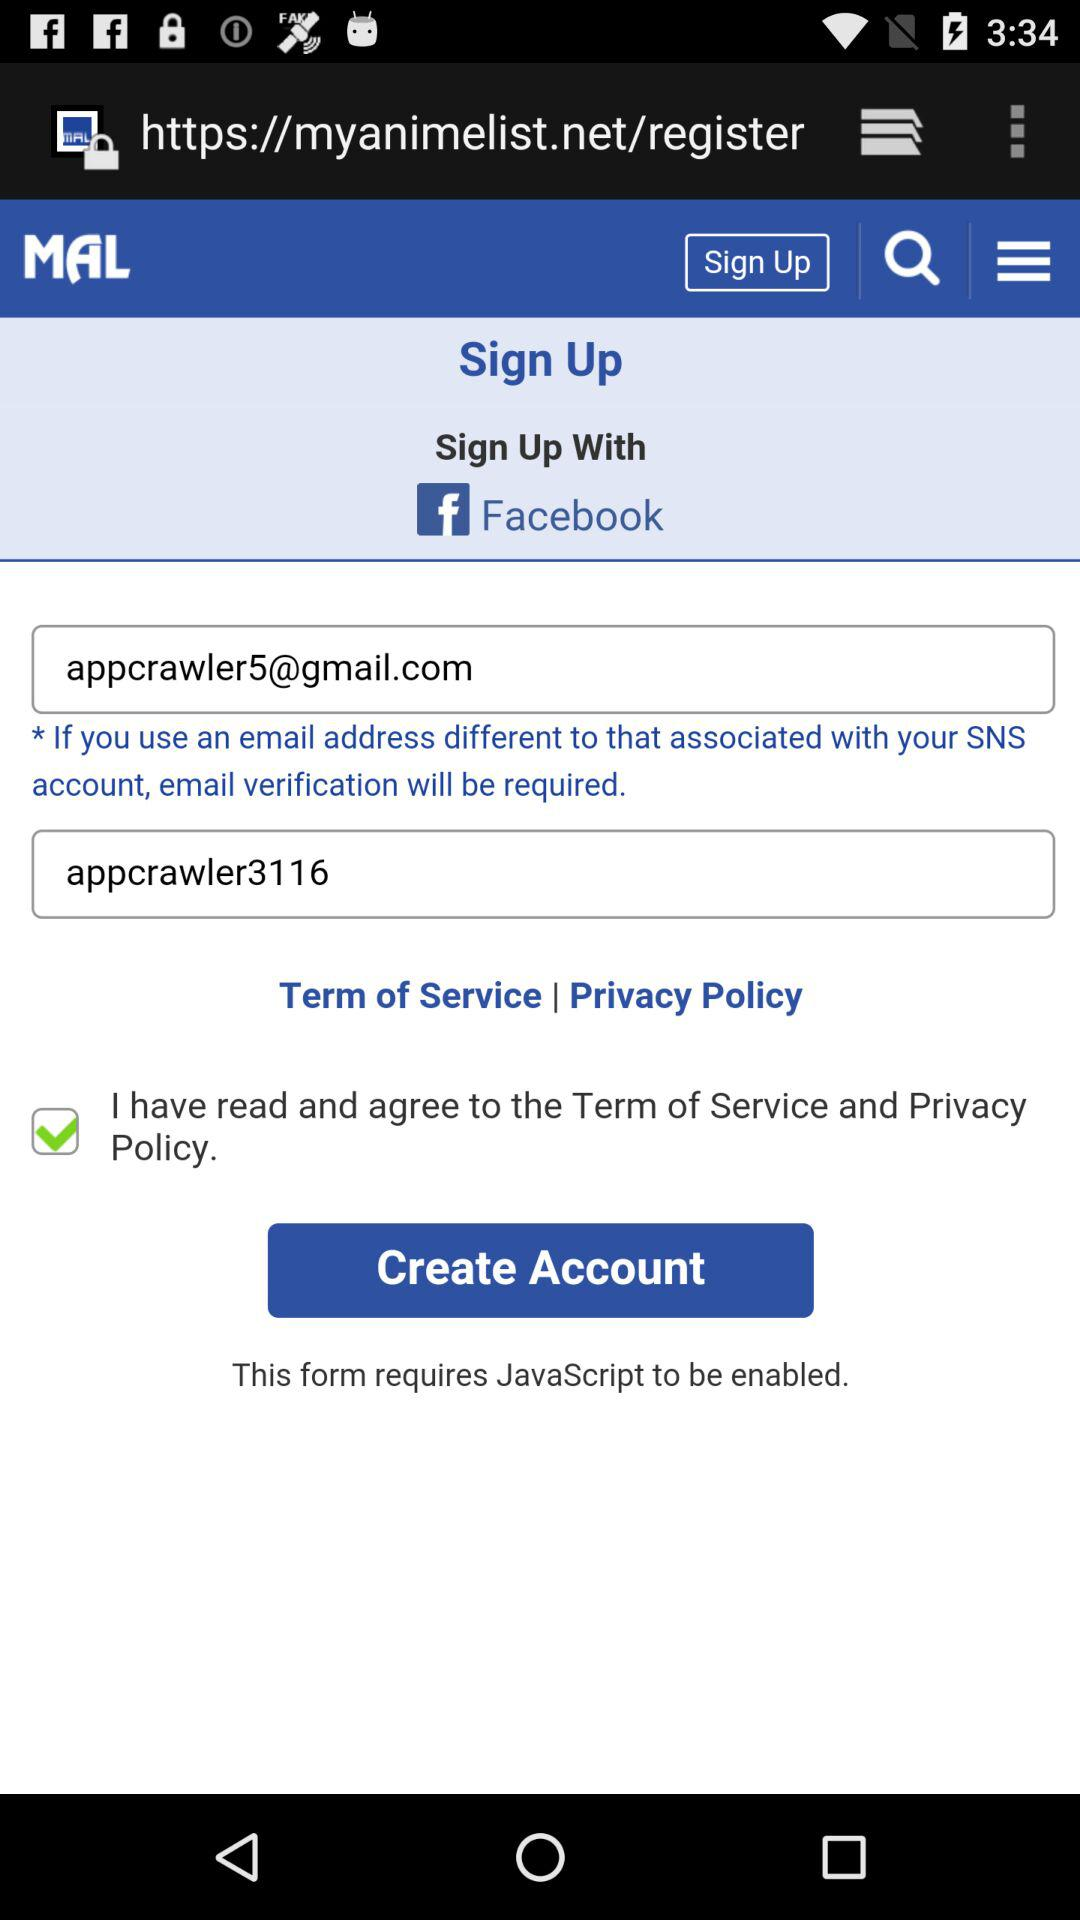How many text inputs are required to create an account?
Answer the question using a single word or phrase. 2 